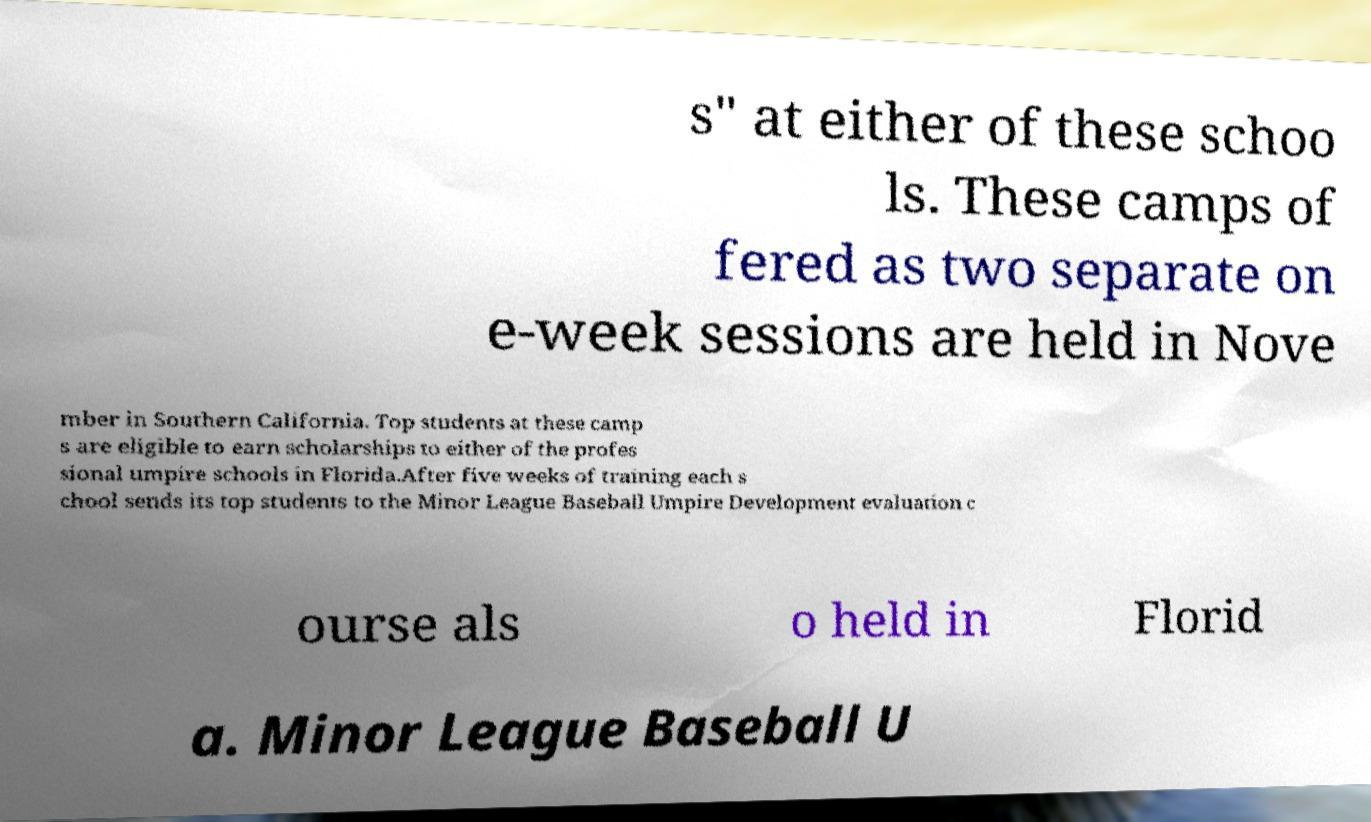Please identify and transcribe the text found in this image. s" at either of these schoo ls. These camps of fered as two separate on e-week sessions are held in Nove mber in Southern California. Top students at these camp s are eligible to earn scholarships to either of the profes sional umpire schools in Florida.After five weeks of training each s chool sends its top students to the Minor League Baseball Umpire Development evaluation c ourse als o held in Florid a. Minor League Baseball U 